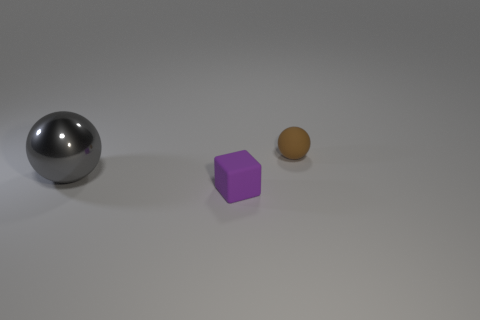Add 2 tiny rubber objects. How many objects exist? 5 Subtract all cubes. How many objects are left? 2 Add 3 gray spheres. How many gray spheres are left? 4 Add 3 large green objects. How many large green objects exist? 3 Subtract 0 brown blocks. How many objects are left? 3 Subtract all gray metal objects. Subtract all small brown matte things. How many objects are left? 1 